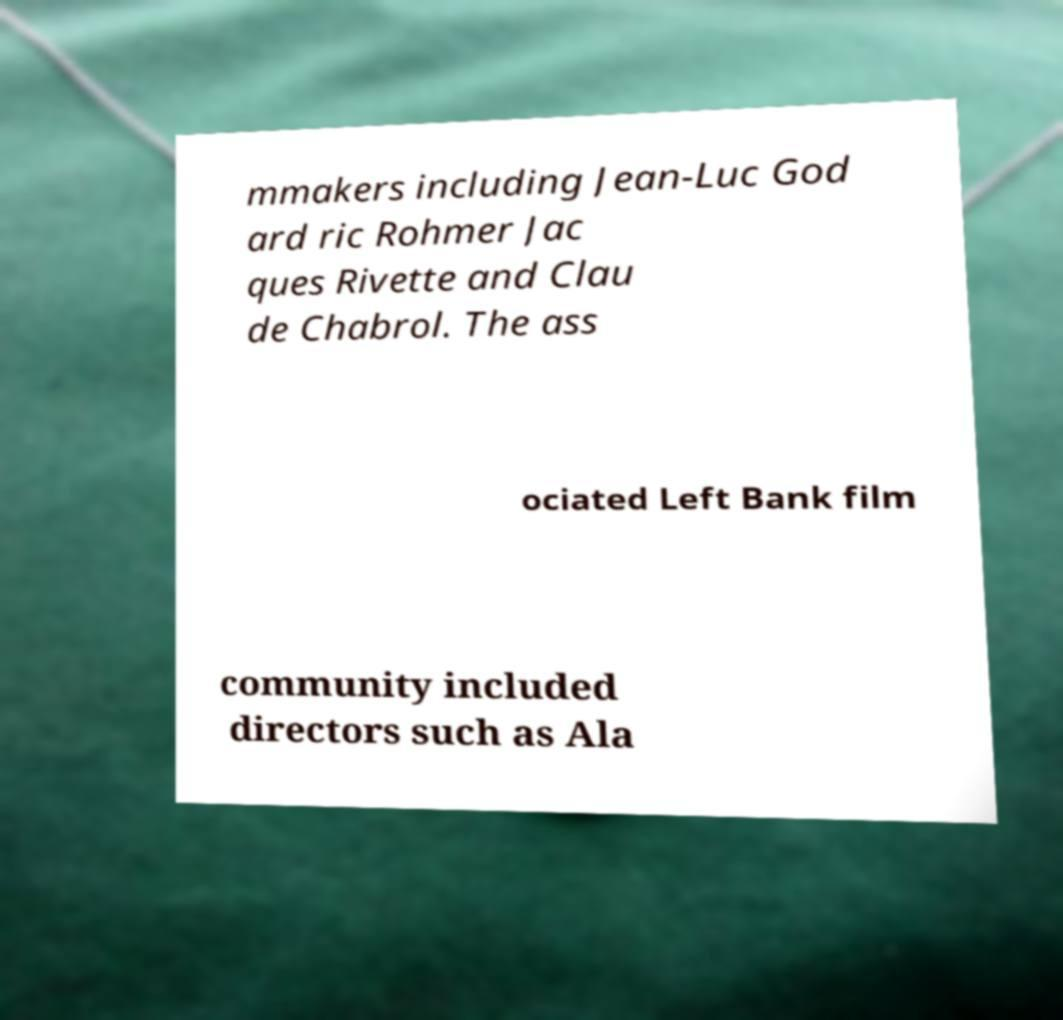Please identify and transcribe the text found in this image. mmakers including Jean-Luc God ard ric Rohmer Jac ques Rivette and Clau de Chabrol. The ass ociated Left Bank film community included directors such as Ala 